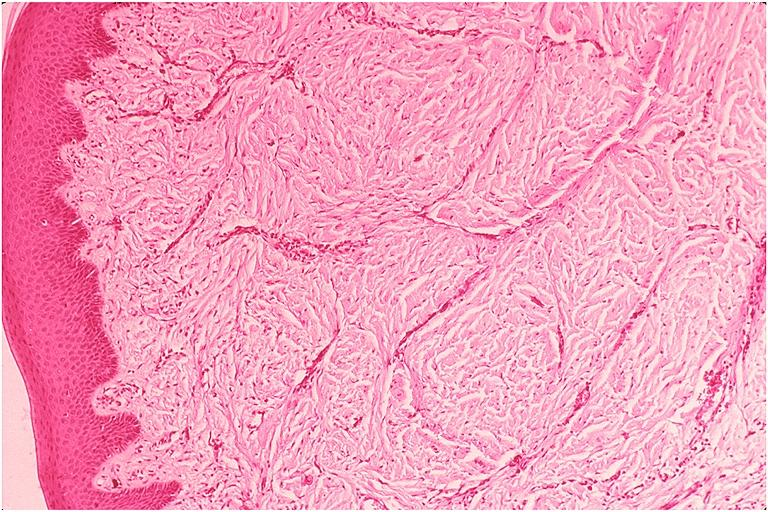where is this?
Answer the question using a single word or phrase. Oral 